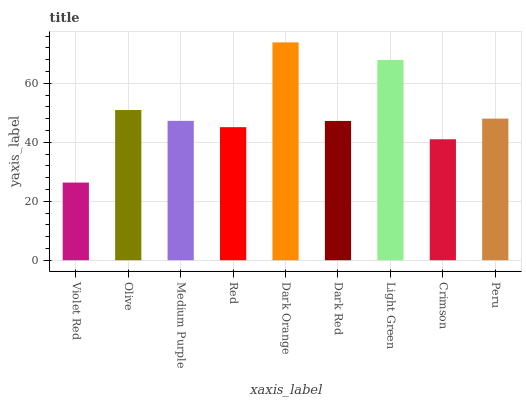Is Violet Red the minimum?
Answer yes or no. Yes. Is Dark Orange the maximum?
Answer yes or no. Yes. Is Olive the minimum?
Answer yes or no. No. Is Olive the maximum?
Answer yes or no. No. Is Olive greater than Violet Red?
Answer yes or no. Yes. Is Violet Red less than Olive?
Answer yes or no. Yes. Is Violet Red greater than Olive?
Answer yes or no. No. Is Olive less than Violet Red?
Answer yes or no. No. Is Medium Purple the high median?
Answer yes or no. Yes. Is Medium Purple the low median?
Answer yes or no. Yes. Is Light Green the high median?
Answer yes or no. No. Is Peru the low median?
Answer yes or no. No. 